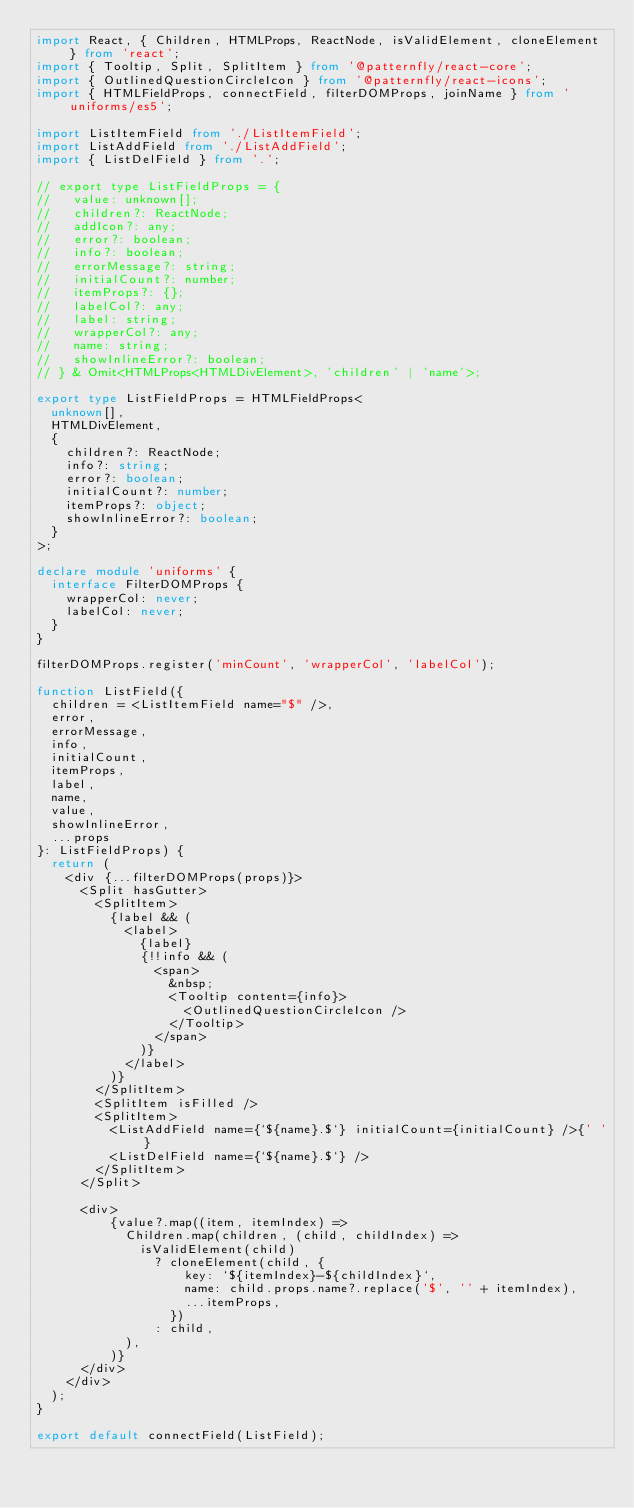Convert code to text. <code><loc_0><loc_0><loc_500><loc_500><_TypeScript_>import React, { Children, HTMLProps, ReactNode, isValidElement, cloneElement } from 'react';
import { Tooltip, Split, SplitItem } from '@patternfly/react-core';
import { OutlinedQuestionCircleIcon } from '@patternfly/react-icons';
import { HTMLFieldProps, connectField, filterDOMProps, joinName } from 'uniforms/es5';

import ListItemField from './ListItemField';
import ListAddField from './ListAddField';
import { ListDelField } from '.';

// export type ListFieldProps = {
//   value: unknown[];
//   children?: ReactNode;
//   addIcon?: any;
//   error?: boolean;
//   info?: boolean;
//   errorMessage?: string;
//   initialCount?: number;
//   itemProps?: {};
//   labelCol?: any;
//   label: string;
//   wrapperCol?: any;
//   name: string;
//   showInlineError?: boolean;
// } & Omit<HTMLProps<HTMLDivElement>, 'children' | 'name'>;

export type ListFieldProps = HTMLFieldProps<
  unknown[],
  HTMLDivElement,
  {
    children?: ReactNode;
    info?: string;
    error?: boolean;
    initialCount?: number;
    itemProps?: object;
    showInlineError?: boolean;
  }
>;

declare module 'uniforms' {
  interface FilterDOMProps {
    wrapperCol: never;
    labelCol: never;
  }
}

filterDOMProps.register('minCount', 'wrapperCol', 'labelCol');

function ListField({
  children = <ListItemField name="$" />,
  error,
  errorMessage,
  info,
  initialCount,
  itemProps,
  label,
  name,
  value,
  showInlineError,
  ...props
}: ListFieldProps) {
  return (
    <div {...filterDOMProps(props)}>
      <Split hasGutter>
        <SplitItem>
          {label && (
            <label>
              {label}
              {!!info && (
                <span>
                  &nbsp;
                  <Tooltip content={info}>
                    <OutlinedQuestionCircleIcon />
                  </Tooltip>
                </span>
              )}
            </label>
          )}
        </SplitItem>
        <SplitItem isFilled />
        <SplitItem>
          <ListAddField name={`${name}.$`} initialCount={initialCount} />{' '}
          <ListDelField name={`${name}.$`} />
        </SplitItem>
      </Split>

      <div>
          {value?.map((item, itemIndex) =>
            Children.map(children, (child, childIndex) =>
              isValidElement(child)
                ? cloneElement(child, {
                    key: `${itemIndex}-${childIndex}`,
                    name: child.props.name?.replace('$', '' + itemIndex),
                    ...itemProps,
                  })
                : child,
            ),
          )}
      </div>
    </div>
  );
}

export default connectField(ListField);
</code> 